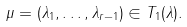Convert formula to latex. <formula><loc_0><loc_0><loc_500><loc_500>\mu = ( \lambda _ { 1 } , \dots , \lambda _ { r - 1 } ) \in T _ { 1 } ( \lambda ) .</formula> 